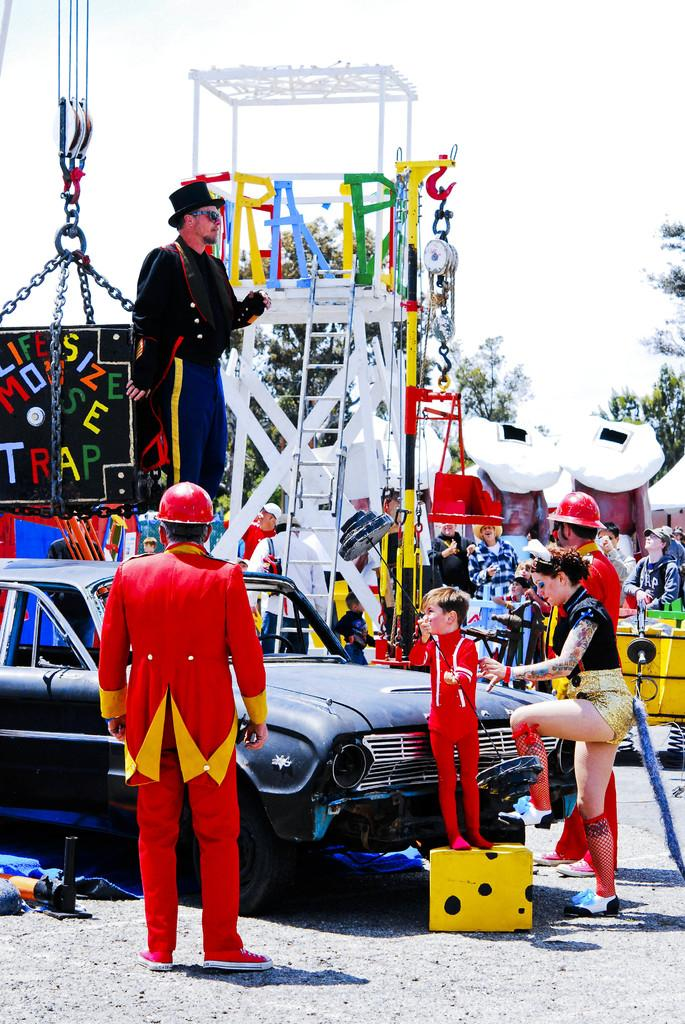How many people are in the group that is visible in the image? There is a group of people standing in the image, but the exact number cannot be determined from the provided facts. What type of vehicle is in the image? There is a car in the image. What is the purpose of the ladder in the image? The purpose of the ladder in the image cannot be determined from the provided facts. What is the crane used for in the image? The crane is visible in the image, but its purpose cannot be determined from the provided facts. What are the chains used for in the image? Chains are present in the image, but their purpose cannot be determined from the provided facts. What type of vegetation is visible in the background of the image? There are trees in the background of the image. What is visible in the sky in the background of the image? The sky is visible in the background of the image. What color is the brain that is visible in the image? There is no brain present in the image. How many chairs are visible in the image? There is no mention of chairs in the provided facts, so we cannot determine how many chairs are visible in the image. 